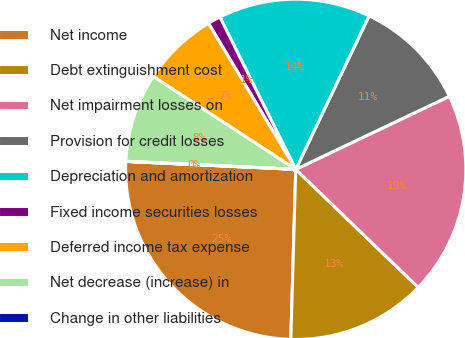Convert chart to OTSL. <chart><loc_0><loc_0><loc_500><loc_500><pie_chart><fcel>Net income<fcel>Debt extinguishment cost<fcel>Net impairment losses on<fcel>Provision for credit losses<fcel>Depreciation and amortization<fcel>Fixed income securities losses<fcel>Deferred income tax expense<fcel>Net decrease (increase) in<fcel>Change in other liabilities<nl><fcel>25.28%<fcel>13.25%<fcel>19.27%<fcel>10.84%<fcel>14.45%<fcel>1.22%<fcel>7.23%<fcel>8.44%<fcel>0.01%<nl></chart> 